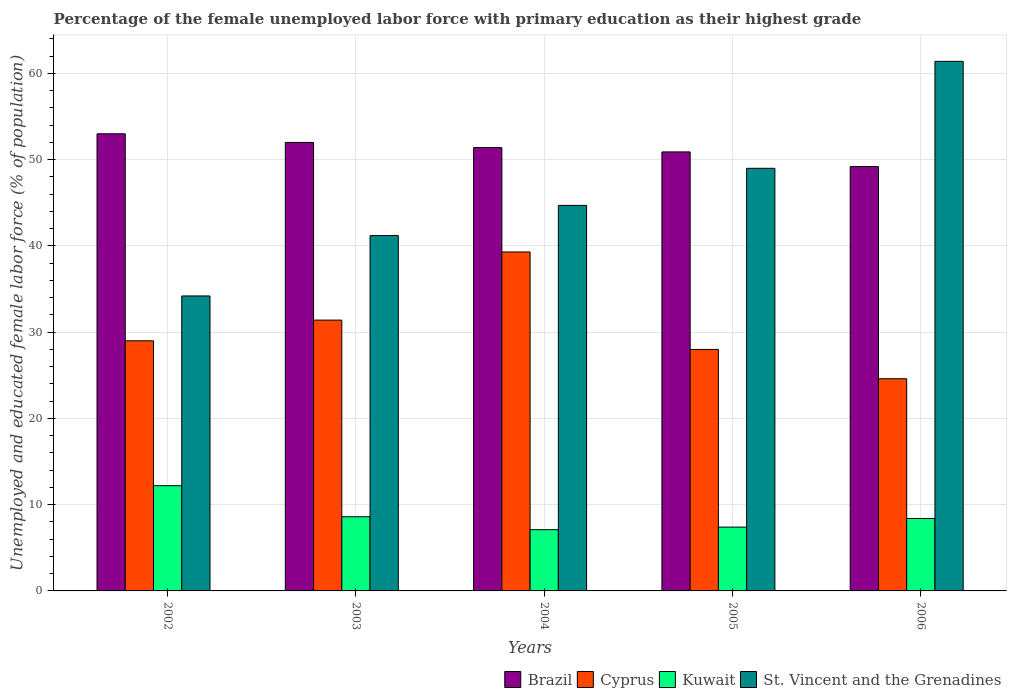How many different coloured bars are there?
Your answer should be compact. 4. How many groups of bars are there?
Your answer should be compact. 5. Are the number of bars per tick equal to the number of legend labels?
Offer a terse response. Yes. Are the number of bars on each tick of the X-axis equal?
Your answer should be very brief. Yes. How many bars are there on the 3rd tick from the left?
Make the answer very short. 4. What is the label of the 4th group of bars from the left?
Provide a succinct answer. 2005. In how many cases, is the number of bars for a given year not equal to the number of legend labels?
Offer a terse response. 0. What is the percentage of the unemployed female labor force with primary education in Cyprus in 2006?
Offer a very short reply. 24.6. Across all years, what is the maximum percentage of the unemployed female labor force with primary education in Kuwait?
Your answer should be very brief. 12.2. Across all years, what is the minimum percentage of the unemployed female labor force with primary education in Cyprus?
Keep it short and to the point. 24.6. In which year was the percentage of the unemployed female labor force with primary education in Cyprus minimum?
Your answer should be very brief. 2006. What is the total percentage of the unemployed female labor force with primary education in Brazil in the graph?
Provide a succinct answer. 256.5. What is the difference between the percentage of the unemployed female labor force with primary education in Brazil in 2003 and that in 2006?
Keep it short and to the point. 2.8. What is the difference between the percentage of the unemployed female labor force with primary education in Kuwait in 2005 and the percentage of the unemployed female labor force with primary education in Brazil in 2002?
Your response must be concise. -45.6. What is the average percentage of the unemployed female labor force with primary education in St. Vincent and the Grenadines per year?
Make the answer very short. 46.1. In the year 2003, what is the difference between the percentage of the unemployed female labor force with primary education in Kuwait and percentage of the unemployed female labor force with primary education in St. Vincent and the Grenadines?
Give a very brief answer. -32.6. What is the ratio of the percentage of the unemployed female labor force with primary education in Brazil in 2002 to that in 2004?
Keep it short and to the point. 1.03. Is the percentage of the unemployed female labor force with primary education in Cyprus in 2003 less than that in 2005?
Provide a succinct answer. No. Is the difference between the percentage of the unemployed female labor force with primary education in Kuwait in 2002 and 2003 greater than the difference between the percentage of the unemployed female labor force with primary education in St. Vincent and the Grenadines in 2002 and 2003?
Provide a short and direct response. Yes. What is the difference between the highest and the second highest percentage of the unemployed female labor force with primary education in Cyprus?
Provide a succinct answer. 7.9. What is the difference between the highest and the lowest percentage of the unemployed female labor force with primary education in Brazil?
Provide a succinct answer. 3.8. In how many years, is the percentage of the unemployed female labor force with primary education in Kuwait greater than the average percentage of the unemployed female labor force with primary education in Kuwait taken over all years?
Keep it short and to the point. 1. Is the sum of the percentage of the unemployed female labor force with primary education in St. Vincent and the Grenadines in 2003 and 2004 greater than the maximum percentage of the unemployed female labor force with primary education in Cyprus across all years?
Give a very brief answer. Yes. Is it the case that in every year, the sum of the percentage of the unemployed female labor force with primary education in St. Vincent and the Grenadines and percentage of the unemployed female labor force with primary education in Cyprus is greater than the sum of percentage of the unemployed female labor force with primary education in Kuwait and percentage of the unemployed female labor force with primary education in Brazil?
Make the answer very short. No. What does the 2nd bar from the right in 2002 represents?
Your response must be concise. Kuwait. Is it the case that in every year, the sum of the percentage of the unemployed female labor force with primary education in Kuwait and percentage of the unemployed female labor force with primary education in Cyprus is greater than the percentage of the unemployed female labor force with primary education in Brazil?
Ensure brevity in your answer.  No. Are all the bars in the graph horizontal?
Make the answer very short. No. How many years are there in the graph?
Offer a very short reply. 5. What is the difference between two consecutive major ticks on the Y-axis?
Give a very brief answer. 10. Does the graph contain any zero values?
Offer a terse response. No. Does the graph contain grids?
Offer a very short reply. Yes. How are the legend labels stacked?
Your answer should be compact. Horizontal. What is the title of the graph?
Your answer should be compact. Percentage of the female unemployed labor force with primary education as their highest grade. What is the label or title of the X-axis?
Ensure brevity in your answer.  Years. What is the label or title of the Y-axis?
Ensure brevity in your answer.  Unemployed and educated female labor force (% of population). What is the Unemployed and educated female labor force (% of population) in Brazil in 2002?
Give a very brief answer. 53. What is the Unemployed and educated female labor force (% of population) in Cyprus in 2002?
Offer a terse response. 29. What is the Unemployed and educated female labor force (% of population) of Kuwait in 2002?
Offer a terse response. 12.2. What is the Unemployed and educated female labor force (% of population) of St. Vincent and the Grenadines in 2002?
Offer a terse response. 34.2. What is the Unemployed and educated female labor force (% of population) of Cyprus in 2003?
Keep it short and to the point. 31.4. What is the Unemployed and educated female labor force (% of population) of Kuwait in 2003?
Offer a very short reply. 8.6. What is the Unemployed and educated female labor force (% of population) in St. Vincent and the Grenadines in 2003?
Offer a terse response. 41.2. What is the Unemployed and educated female labor force (% of population) of Brazil in 2004?
Your response must be concise. 51.4. What is the Unemployed and educated female labor force (% of population) in Cyprus in 2004?
Provide a short and direct response. 39.3. What is the Unemployed and educated female labor force (% of population) of Kuwait in 2004?
Your answer should be very brief. 7.1. What is the Unemployed and educated female labor force (% of population) in St. Vincent and the Grenadines in 2004?
Ensure brevity in your answer.  44.7. What is the Unemployed and educated female labor force (% of population) of Brazil in 2005?
Offer a very short reply. 50.9. What is the Unemployed and educated female labor force (% of population) in Kuwait in 2005?
Provide a succinct answer. 7.4. What is the Unemployed and educated female labor force (% of population) of St. Vincent and the Grenadines in 2005?
Give a very brief answer. 49. What is the Unemployed and educated female labor force (% of population) of Brazil in 2006?
Keep it short and to the point. 49.2. What is the Unemployed and educated female labor force (% of population) of Cyprus in 2006?
Ensure brevity in your answer.  24.6. What is the Unemployed and educated female labor force (% of population) of Kuwait in 2006?
Your answer should be compact. 8.4. What is the Unemployed and educated female labor force (% of population) of St. Vincent and the Grenadines in 2006?
Your answer should be very brief. 61.4. Across all years, what is the maximum Unemployed and educated female labor force (% of population) of Brazil?
Your answer should be compact. 53. Across all years, what is the maximum Unemployed and educated female labor force (% of population) of Cyprus?
Provide a succinct answer. 39.3. Across all years, what is the maximum Unemployed and educated female labor force (% of population) of Kuwait?
Offer a terse response. 12.2. Across all years, what is the maximum Unemployed and educated female labor force (% of population) of St. Vincent and the Grenadines?
Provide a short and direct response. 61.4. Across all years, what is the minimum Unemployed and educated female labor force (% of population) in Brazil?
Your answer should be compact. 49.2. Across all years, what is the minimum Unemployed and educated female labor force (% of population) of Cyprus?
Ensure brevity in your answer.  24.6. Across all years, what is the minimum Unemployed and educated female labor force (% of population) of Kuwait?
Offer a terse response. 7.1. Across all years, what is the minimum Unemployed and educated female labor force (% of population) in St. Vincent and the Grenadines?
Your answer should be compact. 34.2. What is the total Unemployed and educated female labor force (% of population) in Brazil in the graph?
Provide a short and direct response. 256.5. What is the total Unemployed and educated female labor force (% of population) of Cyprus in the graph?
Offer a very short reply. 152.3. What is the total Unemployed and educated female labor force (% of population) of Kuwait in the graph?
Your answer should be compact. 43.7. What is the total Unemployed and educated female labor force (% of population) in St. Vincent and the Grenadines in the graph?
Keep it short and to the point. 230.5. What is the difference between the Unemployed and educated female labor force (% of population) in Cyprus in 2002 and that in 2003?
Your answer should be compact. -2.4. What is the difference between the Unemployed and educated female labor force (% of population) of St. Vincent and the Grenadines in 2002 and that in 2004?
Provide a short and direct response. -10.5. What is the difference between the Unemployed and educated female labor force (% of population) in Cyprus in 2002 and that in 2005?
Make the answer very short. 1. What is the difference between the Unemployed and educated female labor force (% of population) of St. Vincent and the Grenadines in 2002 and that in 2005?
Keep it short and to the point. -14.8. What is the difference between the Unemployed and educated female labor force (% of population) in Brazil in 2002 and that in 2006?
Keep it short and to the point. 3.8. What is the difference between the Unemployed and educated female labor force (% of population) of Kuwait in 2002 and that in 2006?
Provide a succinct answer. 3.8. What is the difference between the Unemployed and educated female labor force (% of population) of St. Vincent and the Grenadines in 2002 and that in 2006?
Provide a succinct answer. -27.2. What is the difference between the Unemployed and educated female labor force (% of population) of St. Vincent and the Grenadines in 2003 and that in 2004?
Offer a very short reply. -3.5. What is the difference between the Unemployed and educated female labor force (% of population) of Brazil in 2003 and that in 2005?
Your response must be concise. 1.1. What is the difference between the Unemployed and educated female labor force (% of population) of Kuwait in 2003 and that in 2005?
Offer a terse response. 1.2. What is the difference between the Unemployed and educated female labor force (% of population) of St. Vincent and the Grenadines in 2003 and that in 2005?
Provide a succinct answer. -7.8. What is the difference between the Unemployed and educated female labor force (% of population) of Brazil in 2003 and that in 2006?
Your answer should be compact. 2.8. What is the difference between the Unemployed and educated female labor force (% of population) in Cyprus in 2003 and that in 2006?
Give a very brief answer. 6.8. What is the difference between the Unemployed and educated female labor force (% of population) in Kuwait in 2003 and that in 2006?
Provide a succinct answer. 0.2. What is the difference between the Unemployed and educated female labor force (% of population) of St. Vincent and the Grenadines in 2003 and that in 2006?
Offer a terse response. -20.2. What is the difference between the Unemployed and educated female labor force (% of population) of Brazil in 2004 and that in 2005?
Offer a terse response. 0.5. What is the difference between the Unemployed and educated female labor force (% of population) in Kuwait in 2004 and that in 2005?
Give a very brief answer. -0.3. What is the difference between the Unemployed and educated female labor force (% of population) of Kuwait in 2004 and that in 2006?
Make the answer very short. -1.3. What is the difference between the Unemployed and educated female labor force (% of population) in St. Vincent and the Grenadines in 2004 and that in 2006?
Ensure brevity in your answer.  -16.7. What is the difference between the Unemployed and educated female labor force (% of population) in Cyprus in 2005 and that in 2006?
Give a very brief answer. 3.4. What is the difference between the Unemployed and educated female labor force (% of population) in St. Vincent and the Grenadines in 2005 and that in 2006?
Your response must be concise. -12.4. What is the difference between the Unemployed and educated female labor force (% of population) in Brazil in 2002 and the Unemployed and educated female labor force (% of population) in Cyprus in 2003?
Provide a short and direct response. 21.6. What is the difference between the Unemployed and educated female labor force (% of population) of Brazil in 2002 and the Unemployed and educated female labor force (% of population) of Kuwait in 2003?
Make the answer very short. 44.4. What is the difference between the Unemployed and educated female labor force (% of population) of Brazil in 2002 and the Unemployed and educated female labor force (% of population) of St. Vincent and the Grenadines in 2003?
Your answer should be very brief. 11.8. What is the difference between the Unemployed and educated female labor force (% of population) of Cyprus in 2002 and the Unemployed and educated female labor force (% of population) of Kuwait in 2003?
Offer a very short reply. 20.4. What is the difference between the Unemployed and educated female labor force (% of population) in Cyprus in 2002 and the Unemployed and educated female labor force (% of population) in St. Vincent and the Grenadines in 2003?
Provide a succinct answer. -12.2. What is the difference between the Unemployed and educated female labor force (% of population) of Brazil in 2002 and the Unemployed and educated female labor force (% of population) of Kuwait in 2004?
Your answer should be compact. 45.9. What is the difference between the Unemployed and educated female labor force (% of population) in Brazil in 2002 and the Unemployed and educated female labor force (% of population) in St. Vincent and the Grenadines in 2004?
Make the answer very short. 8.3. What is the difference between the Unemployed and educated female labor force (% of population) of Cyprus in 2002 and the Unemployed and educated female labor force (% of population) of Kuwait in 2004?
Your response must be concise. 21.9. What is the difference between the Unemployed and educated female labor force (% of population) of Cyprus in 2002 and the Unemployed and educated female labor force (% of population) of St. Vincent and the Grenadines in 2004?
Your answer should be very brief. -15.7. What is the difference between the Unemployed and educated female labor force (% of population) in Kuwait in 2002 and the Unemployed and educated female labor force (% of population) in St. Vincent and the Grenadines in 2004?
Offer a terse response. -32.5. What is the difference between the Unemployed and educated female labor force (% of population) in Brazil in 2002 and the Unemployed and educated female labor force (% of population) in Kuwait in 2005?
Keep it short and to the point. 45.6. What is the difference between the Unemployed and educated female labor force (% of population) in Cyprus in 2002 and the Unemployed and educated female labor force (% of population) in Kuwait in 2005?
Your response must be concise. 21.6. What is the difference between the Unemployed and educated female labor force (% of population) in Kuwait in 2002 and the Unemployed and educated female labor force (% of population) in St. Vincent and the Grenadines in 2005?
Offer a very short reply. -36.8. What is the difference between the Unemployed and educated female labor force (% of population) in Brazil in 2002 and the Unemployed and educated female labor force (% of population) in Cyprus in 2006?
Ensure brevity in your answer.  28.4. What is the difference between the Unemployed and educated female labor force (% of population) in Brazil in 2002 and the Unemployed and educated female labor force (% of population) in Kuwait in 2006?
Give a very brief answer. 44.6. What is the difference between the Unemployed and educated female labor force (% of population) in Cyprus in 2002 and the Unemployed and educated female labor force (% of population) in Kuwait in 2006?
Your response must be concise. 20.6. What is the difference between the Unemployed and educated female labor force (% of population) in Cyprus in 2002 and the Unemployed and educated female labor force (% of population) in St. Vincent and the Grenadines in 2006?
Ensure brevity in your answer.  -32.4. What is the difference between the Unemployed and educated female labor force (% of population) of Kuwait in 2002 and the Unemployed and educated female labor force (% of population) of St. Vincent and the Grenadines in 2006?
Your answer should be compact. -49.2. What is the difference between the Unemployed and educated female labor force (% of population) of Brazil in 2003 and the Unemployed and educated female labor force (% of population) of Cyprus in 2004?
Your answer should be compact. 12.7. What is the difference between the Unemployed and educated female labor force (% of population) in Brazil in 2003 and the Unemployed and educated female labor force (% of population) in Kuwait in 2004?
Offer a terse response. 44.9. What is the difference between the Unemployed and educated female labor force (% of population) in Brazil in 2003 and the Unemployed and educated female labor force (% of population) in St. Vincent and the Grenadines in 2004?
Provide a succinct answer. 7.3. What is the difference between the Unemployed and educated female labor force (% of population) in Cyprus in 2003 and the Unemployed and educated female labor force (% of population) in Kuwait in 2004?
Your answer should be very brief. 24.3. What is the difference between the Unemployed and educated female labor force (% of population) of Kuwait in 2003 and the Unemployed and educated female labor force (% of population) of St. Vincent and the Grenadines in 2004?
Keep it short and to the point. -36.1. What is the difference between the Unemployed and educated female labor force (% of population) in Brazil in 2003 and the Unemployed and educated female labor force (% of population) in Kuwait in 2005?
Offer a terse response. 44.6. What is the difference between the Unemployed and educated female labor force (% of population) in Brazil in 2003 and the Unemployed and educated female labor force (% of population) in St. Vincent and the Grenadines in 2005?
Your answer should be very brief. 3. What is the difference between the Unemployed and educated female labor force (% of population) of Cyprus in 2003 and the Unemployed and educated female labor force (% of population) of St. Vincent and the Grenadines in 2005?
Offer a terse response. -17.6. What is the difference between the Unemployed and educated female labor force (% of population) in Kuwait in 2003 and the Unemployed and educated female labor force (% of population) in St. Vincent and the Grenadines in 2005?
Your answer should be compact. -40.4. What is the difference between the Unemployed and educated female labor force (% of population) in Brazil in 2003 and the Unemployed and educated female labor force (% of population) in Cyprus in 2006?
Offer a terse response. 27.4. What is the difference between the Unemployed and educated female labor force (% of population) in Brazil in 2003 and the Unemployed and educated female labor force (% of population) in Kuwait in 2006?
Provide a succinct answer. 43.6. What is the difference between the Unemployed and educated female labor force (% of population) in Cyprus in 2003 and the Unemployed and educated female labor force (% of population) in Kuwait in 2006?
Your answer should be very brief. 23. What is the difference between the Unemployed and educated female labor force (% of population) in Kuwait in 2003 and the Unemployed and educated female labor force (% of population) in St. Vincent and the Grenadines in 2006?
Keep it short and to the point. -52.8. What is the difference between the Unemployed and educated female labor force (% of population) in Brazil in 2004 and the Unemployed and educated female labor force (% of population) in Cyprus in 2005?
Keep it short and to the point. 23.4. What is the difference between the Unemployed and educated female labor force (% of population) in Brazil in 2004 and the Unemployed and educated female labor force (% of population) in St. Vincent and the Grenadines in 2005?
Your answer should be compact. 2.4. What is the difference between the Unemployed and educated female labor force (% of population) in Cyprus in 2004 and the Unemployed and educated female labor force (% of population) in Kuwait in 2005?
Give a very brief answer. 31.9. What is the difference between the Unemployed and educated female labor force (% of population) in Cyprus in 2004 and the Unemployed and educated female labor force (% of population) in St. Vincent and the Grenadines in 2005?
Provide a succinct answer. -9.7. What is the difference between the Unemployed and educated female labor force (% of population) of Kuwait in 2004 and the Unemployed and educated female labor force (% of population) of St. Vincent and the Grenadines in 2005?
Ensure brevity in your answer.  -41.9. What is the difference between the Unemployed and educated female labor force (% of population) in Brazil in 2004 and the Unemployed and educated female labor force (% of population) in Cyprus in 2006?
Make the answer very short. 26.8. What is the difference between the Unemployed and educated female labor force (% of population) in Brazil in 2004 and the Unemployed and educated female labor force (% of population) in Kuwait in 2006?
Ensure brevity in your answer.  43. What is the difference between the Unemployed and educated female labor force (% of population) in Cyprus in 2004 and the Unemployed and educated female labor force (% of population) in Kuwait in 2006?
Provide a succinct answer. 30.9. What is the difference between the Unemployed and educated female labor force (% of population) in Cyprus in 2004 and the Unemployed and educated female labor force (% of population) in St. Vincent and the Grenadines in 2006?
Provide a succinct answer. -22.1. What is the difference between the Unemployed and educated female labor force (% of population) in Kuwait in 2004 and the Unemployed and educated female labor force (% of population) in St. Vincent and the Grenadines in 2006?
Provide a succinct answer. -54.3. What is the difference between the Unemployed and educated female labor force (% of population) of Brazil in 2005 and the Unemployed and educated female labor force (% of population) of Cyprus in 2006?
Offer a very short reply. 26.3. What is the difference between the Unemployed and educated female labor force (% of population) in Brazil in 2005 and the Unemployed and educated female labor force (% of population) in Kuwait in 2006?
Provide a succinct answer. 42.5. What is the difference between the Unemployed and educated female labor force (% of population) of Cyprus in 2005 and the Unemployed and educated female labor force (% of population) of Kuwait in 2006?
Provide a short and direct response. 19.6. What is the difference between the Unemployed and educated female labor force (% of population) in Cyprus in 2005 and the Unemployed and educated female labor force (% of population) in St. Vincent and the Grenadines in 2006?
Your answer should be compact. -33.4. What is the difference between the Unemployed and educated female labor force (% of population) of Kuwait in 2005 and the Unemployed and educated female labor force (% of population) of St. Vincent and the Grenadines in 2006?
Your response must be concise. -54. What is the average Unemployed and educated female labor force (% of population) in Brazil per year?
Give a very brief answer. 51.3. What is the average Unemployed and educated female labor force (% of population) of Cyprus per year?
Ensure brevity in your answer.  30.46. What is the average Unemployed and educated female labor force (% of population) in Kuwait per year?
Your answer should be compact. 8.74. What is the average Unemployed and educated female labor force (% of population) of St. Vincent and the Grenadines per year?
Make the answer very short. 46.1. In the year 2002, what is the difference between the Unemployed and educated female labor force (% of population) of Brazil and Unemployed and educated female labor force (% of population) of Kuwait?
Provide a short and direct response. 40.8. In the year 2002, what is the difference between the Unemployed and educated female labor force (% of population) in Brazil and Unemployed and educated female labor force (% of population) in St. Vincent and the Grenadines?
Your response must be concise. 18.8. In the year 2002, what is the difference between the Unemployed and educated female labor force (% of population) in Kuwait and Unemployed and educated female labor force (% of population) in St. Vincent and the Grenadines?
Your answer should be compact. -22. In the year 2003, what is the difference between the Unemployed and educated female labor force (% of population) in Brazil and Unemployed and educated female labor force (% of population) in Cyprus?
Your answer should be compact. 20.6. In the year 2003, what is the difference between the Unemployed and educated female labor force (% of population) in Brazil and Unemployed and educated female labor force (% of population) in Kuwait?
Offer a terse response. 43.4. In the year 2003, what is the difference between the Unemployed and educated female labor force (% of population) of Cyprus and Unemployed and educated female labor force (% of population) of Kuwait?
Offer a terse response. 22.8. In the year 2003, what is the difference between the Unemployed and educated female labor force (% of population) in Cyprus and Unemployed and educated female labor force (% of population) in St. Vincent and the Grenadines?
Ensure brevity in your answer.  -9.8. In the year 2003, what is the difference between the Unemployed and educated female labor force (% of population) in Kuwait and Unemployed and educated female labor force (% of population) in St. Vincent and the Grenadines?
Give a very brief answer. -32.6. In the year 2004, what is the difference between the Unemployed and educated female labor force (% of population) of Brazil and Unemployed and educated female labor force (% of population) of Kuwait?
Your answer should be very brief. 44.3. In the year 2004, what is the difference between the Unemployed and educated female labor force (% of population) in Brazil and Unemployed and educated female labor force (% of population) in St. Vincent and the Grenadines?
Provide a succinct answer. 6.7. In the year 2004, what is the difference between the Unemployed and educated female labor force (% of population) in Cyprus and Unemployed and educated female labor force (% of population) in Kuwait?
Keep it short and to the point. 32.2. In the year 2004, what is the difference between the Unemployed and educated female labor force (% of population) of Kuwait and Unemployed and educated female labor force (% of population) of St. Vincent and the Grenadines?
Give a very brief answer. -37.6. In the year 2005, what is the difference between the Unemployed and educated female labor force (% of population) in Brazil and Unemployed and educated female labor force (% of population) in Cyprus?
Your answer should be compact. 22.9. In the year 2005, what is the difference between the Unemployed and educated female labor force (% of population) in Brazil and Unemployed and educated female labor force (% of population) in Kuwait?
Your answer should be very brief. 43.5. In the year 2005, what is the difference between the Unemployed and educated female labor force (% of population) in Brazil and Unemployed and educated female labor force (% of population) in St. Vincent and the Grenadines?
Your response must be concise. 1.9. In the year 2005, what is the difference between the Unemployed and educated female labor force (% of population) of Cyprus and Unemployed and educated female labor force (% of population) of Kuwait?
Provide a short and direct response. 20.6. In the year 2005, what is the difference between the Unemployed and educated female labor force (% of population) in Cyprus and Unemployed and educated female labor force (% of population) in St. Vincent and the Grenadines?
Your response must be concise. -21. In the year 2005, what is the difference between the Unemployed and educated female labor force (% of population) of Kuwait and Unemployed and educated female labor force (% of population) of St. Vincent and the Grenadines?
Your response must be concise. -41.6. In the year 2006, what is the difference between the Unemployed and educated female labor force (% of population) in Brazil and Unemployed and educated female labor force (% of population) in Cyprus?
Provide a succinct answer. 24.6. In the year 2006, what is the difference between the Unemployed and educated female labor force (% of population) in Brazil and Unemployed and educated female labor force (% of population) in Kuwait?
Offer a terse response. 40.8. In the year 2006, what is the difference between the Unemployed and educated female labor force (% of population) in Brazil and Unemployed and educated female labor force (% of population) in St. Vincent and the Grenadines?
Offer a terse response. -12.2. In the year 2006, what is the difference between the Unemployed and educated female labor force (% of population) in Cyprus and Unemployed and educated female labor force (% of population) in Kuwait?
Your answer should be compact. 16.2. In the year 2006, what is the difference between the Unemployed and educated female labor force (% of population) of Cyprus and Unemployed and educated female labor force (% of population) of St. Vincent and the Grenadines?
Your answer should be very brief. -36.8. In the year 2006, what is the difference between the Unemployed and educated female labor force (% of population) in Kuwait and Unemployed and educated female labor force (% of population) in St. Vincent and the Grenadines?
Offer a terse response. -53. What is the ratio of the Unemployed and educated female labor force (% of population) in Brazil in 2002 to that in 2003?
Make the answer very short. 1.02. What is the ratio of the Unemployed and educated female labor force (% of population) of Cyprus in 2002 to that in 2003?
Keep it short and to the point. 0.92. What is the ratio of the Unemployed and educated female labor force (% of population) in Kuwait in 2002 to that in 2003?
Give a very brief answer. 1.42. What is the ratio of the Unemployed and educated female labor force (% of population) in St. Vincent and the Grenadines in 2002 to that in 2003?
Keep it short and to the point. 0.83. What is the ratio of the Unemployed and educated female labor force (% of population) in Brazil in 2002 to that in 2004?
Your answer should be very brief. 1.03. What is the ratio of the Unemployed and educated female labor force (% of population) in Cyprus in 2002 to that in 2004?
Provide a short and direct response. 0.74. What is the ratio of the Unemployed and educated female labor force (% of population) of Kuwait in 2002 to that in 2004?
Keep it short and to the point. 1.72. What is the ratio of the Unemployed and educated female labor force (% of population) of St. Vincent and the Grenadines in 2002 to that in 2004?
Make the answer very short. 0.77. What is the ratio of the Unemployed and educated female labor force (% of population) of Brazil in 2002 to that in 2005?
Provide a short and direct response. 1.04. What is the ratio of the Unemployed and educated female labor force (% of population) of Cyprus in 2002 to that in 2005?
Provide a succinct answer. 1.04. What is the ratio of the Unemployed and educated female labor force (% of population) of Kuwait in 2002 to that in 2005?
Offer a terse response. 1.65. What is the ratio of the Unemployed and educated female labor force (% of population) in St. Vincent and the Grenadines in 2002 to that in 2005?
Your answer should be very brief. 0.7. What is the ratio of the Unemployed and educated female labor force (% of population) in Brazil in 2002 to that in 2006?
Ensure brevity in your answer.  1.08. What is the ratio of the Unemployed and educated female labor force (% of population) of Cyprus in 2002 to that in 2006?
Offer a very short reply. 1.18. What is the ratio of the Unemployed and educated female labor force (% of population) of Kuwait in 2002 to that in 2006?
Your answer should be very brief. 1.45. What is the ratio of the Unemployed and educated female labor force (% of population) in St. Vincent and the Grenadines in 2002 to that in 2006?
Offer a terse response. 0.56. What is the ratio of the Unemployed and educated female labor force (% of population) in Brazil in 2003 to that in 2004?
Your answer should be compact. 1.01. What is the ratio of the Unemployed and educated female labor force (% of population) in Cyprus in 2003 to that in 2004?
Offer a terse response. 0.8. What is the ratio of the Unemployed and educated female labor force (% of population) of Kuwait in 2003 to that in 2004?
Give a very brief answer. 1.21. What is the ratio of the Unemployed and educated female labor force (% of population) in St. Vincent and the Grenadines in 2003 to that in 2004?
Your response must be concise. 0.92. What is the ratio of the Unemployed and educated female labor force (% of population) of Brazil in 2003 to that in 2005?
Keep it short and to the point. 1.02. What is the ratio of the Unemployed and educated female labor force (% of population) in Cyprus in 2003 to that in 2005?
Offer a very short reply. 1.12. What is the ratio of the Unemployed and educated female labor force (% of population) of Kuwait in 2003 to that in 2005?
Offer a very short reply. 1.16. What is the ratio of the Unemployed and educated female labor force (% of population) of St. Vincent and the Grenadines in 2003 to that in 2005?
Your answer should be very brief. 0.84. What is the ratio of the Unemployed and educated female labor force (% of population) in Brazil in 2003 to that in 2006?
Make the answer very short. 1.06. What is the ratio of the Unemployed and educated female labor force (% of population) of Cyprus in 2003 to that in 2006?
Your answer should be compact. 1.28. What is the ratio of the Unemployed and educated female labor force (% of population) in Kuwait in 2003 to that in 2006?
Keep it short and to the point. 1.02. What is the ratio of the Unemployed and educated female labor force (% of population) of St. Vincent and the Grenadines in 2003 to that in 2006?
Your answer should be very brief. 0.67. What is the ratio of the Unemployed and educated female labor force (% of population) of Brazil in 2004 to that in 2005?
Give a very brief answer. 1.01. What is the ratio of the Unemployed and educated female labor force (% of population) of Cyprus in 2004 to that in 2005?
Your answer should be compact. 1.4. What is the ratio of the Unemployed and educated female labor force (% of population) of Kuwait in 2004 to that in 2005?
Make the answer very short. 0.96. What is the ratio of the Unemployed and educated female labor force (% of population) of St. Vincent and the Grenadines in 2004 to that in 2005?
Give a very brief answer. 0.91. What is the ratio of the Unemployed and educated female labor force (% of population) of Brazil in 2004 to that in 2006?
Your response must be concise. 1.04. What is the ratio of the Unemployed and educated female labor force (% of population) in Cyprus in 2004 to that in 2006?
Ensure brevity in your answer.  1.6. What is the ratio of the Unemployed and educated female labor force (% of population) of Kuwait in 2004 to that in 2006?
Offer a terse response. 0.85. What is the ratio of the Unemployed and educated female labor force (% of population) of St. Vincent and the Grenadines in 2004 to that in 2006?
Offer a terse response. 0.73. What is the ratio of the Unemployed and educated female labor force (% of population) of Brazil in 2005 to that in 2006?
Ensure brevity in your answer.  1.03. What is the ratio of the Unemployed and educated female labor force (% of population) in Cyprus in 2005 to that in 2006?
Ensure brevity in your answer.  1.14. What is the ratio of the Unemployed and educated female labor force (% of population) of Kuwait in 2005 to that in 2006?
Provide a succinct answer. 0.88. What is the ratio of the Unemployed and educated female labor force (% of population) of St. Vincent and the Grenadines in 2005 to that in 2006?
Ensure brevity in your answer.  0.8. What is the difference between the highest and the second highest Unemployed and educated female labor force (% of population) in Kuwait?
Give a very brief answer. 3.6. What is the difference between the highest and the second highest Unemployed and educated female labor force (% of population) in St. Vincent and the Grenadines?
Your answer should be compact. 12.4. What is the difference between the highest and the lowest Unemployed and educated female labor force (% of population) in Brazil?
Keep it short and to the point. 3.8. What is the difference between the highest and the lowest Unemployed and educated female labor force (% of population) in Cyprus?
Provide a short and direct response. 14.7. What is the difference between the highest and the lowest Unemployed and educated female labor force (% of population) in Kuwait?
Keep it short and to the point. 5.1. What is the difference between the highest and the lowest Unemployed and educated female labor force (% of population) of St. Vincent and the Grenadines?
Provide a short and direct response. 27.2. 